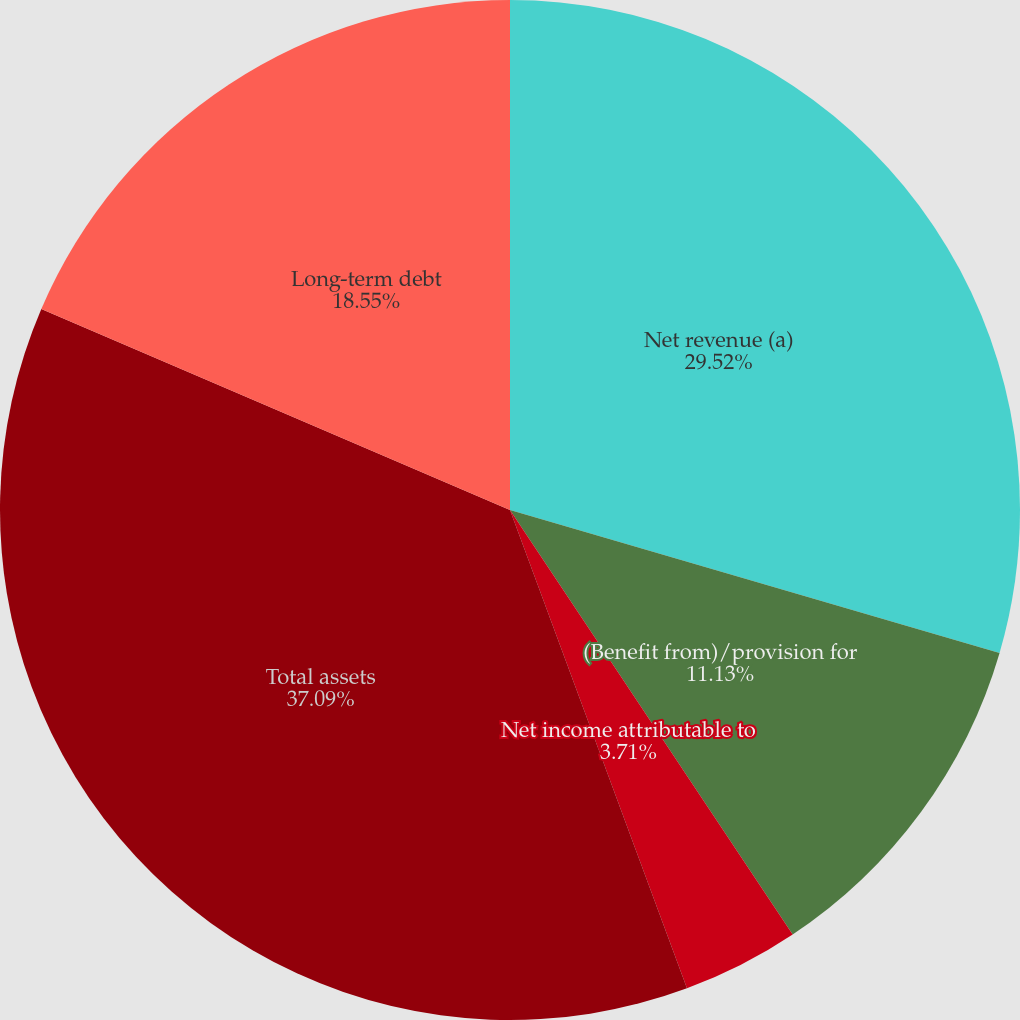Convert chart to OTSL. <chart><loc_0><loc_0><loc_500><loc_500><pie_chart><fcel>Net revenue (a)<fcel>(Benefit from)/provision for<fcel>Net income attributable to<fcel>Cash dividends declared per<fcel>Total assets<fcel>Long-term debt<nl><fcel>29.52%<fcel>11.13%<fcel>3.71%<fcel>0.0%<fcel>37.09%<fcel>18.55%<nl></chart> 